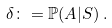Convert formula to latex. <formula><loc_0><loc_0><loc_500><loc_500>\delta \colon = \mathbb { P } ( A | S ) \, .</formula> 